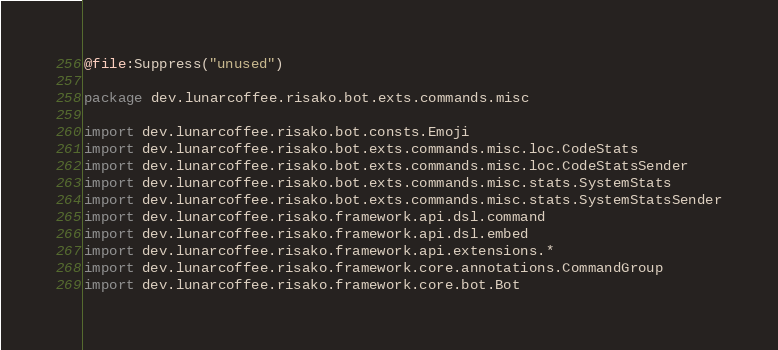<code> <loc_0><loc_0><loc_500><loc_500><_Kotlin_>@file:Suppress("unused")

package dev.lunarcoffee.risako.bot.exts.commands.misc

import dev.lunarcoffee.risako.bot.consts.Emoji
import dev.lunarcoffee.risako.bot.exts.commands.misc.loc.CodeStats
import dev.lunarcoffee.risako.bot.exts.commands.misc.loc.CodeStatsSender
import dev.lunarcoffee.risako.bot.exts.commands.misc.stats.SystemStats
import dev.lunarcoffee.risako.bot.exts.commands.misc.stats.SystemStatsSender
import dev.lunarcoffee.risako.framework.api.dsl.command
import dev.lunarcoffee.risako.framework.api.dsl.embed
import dev.lunarcoffee.risako.framework.api.extensions.*
import dev.lunarcoffee.risako.framework.core.annotations.CommandGroup
import dev.lunarcoffee.risako.framework.core.bot.Bot</code> 